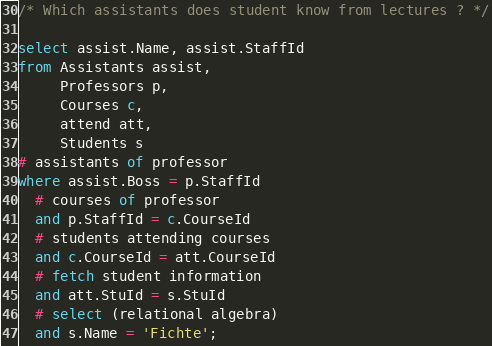Convert code to text. <code><loc_0><loc_0><loc_500><loc_500><_SQL_>/* Which assistants does student know from lectures ? */

select assist.Name, assist.StaffId
from Assistants assist,
     Professors p,
     Courses c,
     attend att,
     Students s
# assistants of professor
where assist.Boss = p.StaffId
  # courses of professor
  and p.StaffId = c.CourseId
  # students attending courses
  and c.CourseId = att.CourseId
  # fetch student information
  and att.StuId = s.StuId
  # select (relational algebra)
  and s.Name = 'Fichte';</code> 